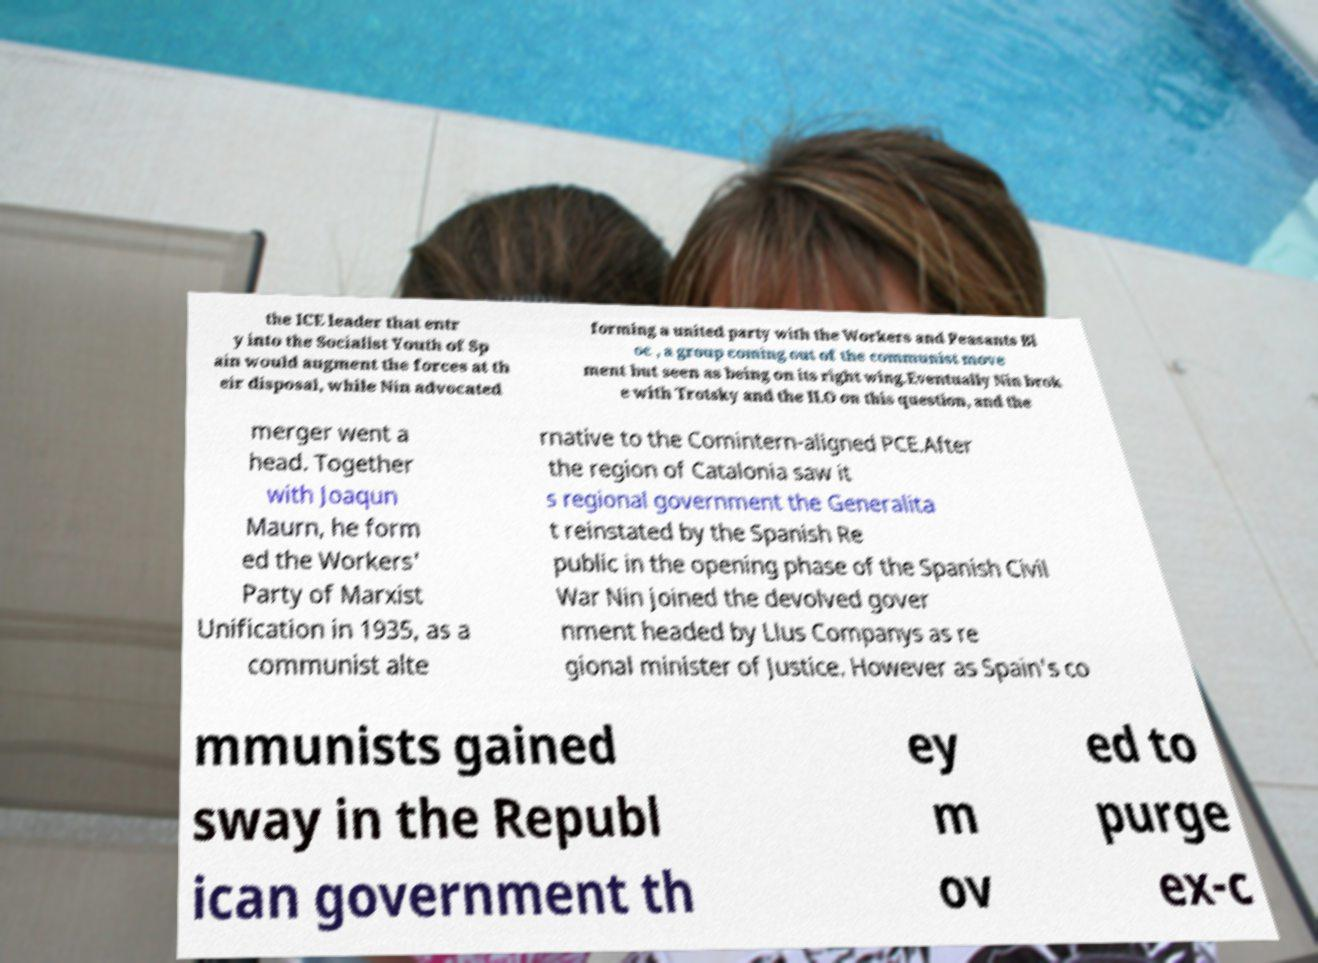Can you read and provide the text displayed in the image?This photo seems to have some interesting text. Can you extract and type it out for me? the ICE leader that entr y into the Socialist Youth of Sp ain would augment the forces at th eir disposal, while Nin advocated forming a united party with the Workers and Peasants Bl oc , a group coming out of the communist move ment but seen as being on its right wing.Eventually Nin brok e with Trotsky and the ILO on this question, and the merger went a head. Together with Joaqun Maurn, he form ed the Workers' Party of Marxist Unification in 1935, as a communist alte rnative to the Comintern-aligned PCE.After the region of Catalonia saw it s regional government the Generalita t reinstated by the Spanish Re public in the opening phase of the Spanish Civil War Nin joined the devolved gover nment headed by Llus Companys as re gional minister of Justice. However as Spain's co mmunists gained sway in the Republ ican government th ey m ov ed to purge ex-c 